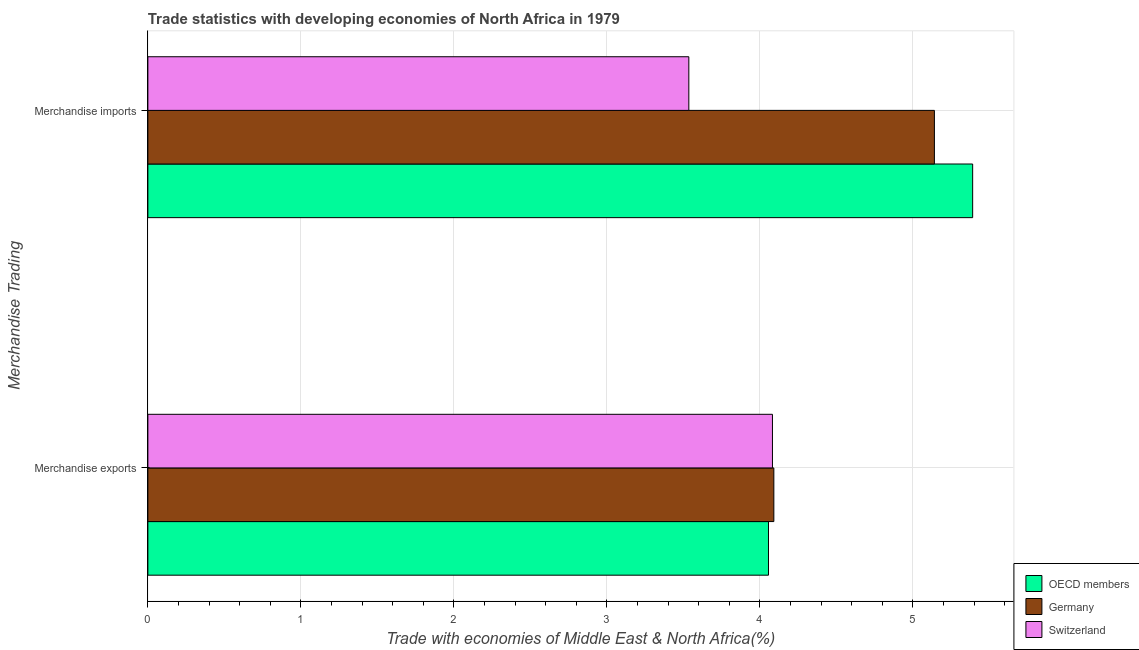How many different coloured bars are there?
Your answer should be compact. 3. How many groups of bars are there?
Ensure brevity in your answer.  2. How many bars are there on the 2nd tick from the top?
Your response must be concise. 3. What is the label of the 2nd group of bars from the top?
Offer a terse response. Merchandise exports. What is the merchandise imports in Germany?
Offer a terse response. 5.14. Across all countries, what is the maximum merchandise exports?
Ensure brevity in your answer.  4.09. Across all countries, what is the minimum merchandise exports?
Your answer should be very brief. 4.06. In which country was the merchandise exports maximum?
Make the answer very short. Germany. In which country was the merchandise exports minimum?
Your response must be concise. OECD members. What is the total merchandise imports in the graph?
Offer a terse response. 14.07. What is the difference between the merchandise imports in Germany and that in Switzerland?
Ensure brevity in your answer.  1.61. What is the difference between the merchandise exports in Switzerland and the merchandise imports in OECD members?
Provide a short and direct response. -1.31. What is the average merchandise imports per country?
Offer a very short reply. 4.69. What is the difference between the merchandise imports and merchandise exports in OECD members?
Make the answer very short. 1.33. What is the ratio of the merchandise imports in Switzerland to that in OECD members?
Offer a very short reply. 0.66. What does the 1st bar from the top in Merchandise exports represents?
Your answer should be compact. Switzerland. What is the difference between two consecutive major ticks on the X-axis?
Give a very brief answer. 1. Does the graph contain any zero values?
Offer a terse response. No. Does the graph contain grids?
Offer a very short reply. Yes. How are the legend labels stacked?
Offer a very short reply. Vertical. What is the title of the graph?
Make the answer very short. Trade statistics with developing economies of North Africa in 1979. Does "Guam" appear as one of the legend labels in the graph?
Make the answer very short. No. What is the label or title of the X-axis?
Provide a succinct answer. Trade with economies of Middle East & North Africa(%). What is the label or title of the Y-axis?
Offer a very short reply. Merchandise Trading. What is the Trade with economies of Middle East & North Africa(%) of OECD members in Merchandise exports?
Give a very brief answer. 4.06. What is the Trade with economies of Middle East & North Africa(%) of Germany in Merchandise exports?
Make the answer very short. 4.09. What is the Trade with economies of Middle East & North Africa(%) in Switzerland in Merchandise exports?
Make the answer very short. 4.08. What is the Trade with economies of Middle East & North Africa(%) in OECD members in Merchandise imports?
Your response must be concise. 5.39. What is the Trade with economies of Middle East & North Africa(%) of Germany in Merchandise imports?
Keep it short and to the point. 5.14. What is the Trade with economies of Middle East & North Africa(%) in Switzerland in Merchandise imports?
Offer a very short reply. 3.54. Across all Merchandise Trading, what is the maximum Trade with economies of Middle East & North Africa(%) of OECD members?
Provide a succinct answer. 5.39. Across all Merchandise Trading, what is the maximum Trade with economies of Middle East & North Africa(%) of Germany?
Offer a terse response. 5.14. Across all Merchandise Trading, what is the maximum Trade with economies of Middle East & North Africa(%) of Switzerland?
Keep it short and to the point. 4.08. Across all Merchandise Trading, what is the minimum Trade with economies of Middle East & North Africa(%) of OECD members?
Your answer should be compact. 4.06. Across all Merchandise Trading, what is the minimum Trade with economies of Middle East & North Africa(%) of Germany?
Your response must be concise. 4.09. Across all Merchandise Trading, what is the minimum Trade with economies of Middle East & North Africa(%) of Switzerland?
Ensure brevity in your answer.  3.54. What is the total Trade with economies of Middle East & North Africa(%) in OECD members in the graph?
Offer a terse response. 9.45. What is the total Trade with economies of Middle East & North Africa(%) of Germany in the graph?
Your answer should be very brief. 9.23. What is the total Trade with economies of Middle East & North Africa(%) in Switzerland in the graph?
Provide a succinct answer. 7.62. What is the difference between the Trade with economies of Middle East & North Africa(%) in OECD members in Merchandise exports and that in Merchandise imports?
Your answer should be compact. -1.33. What is the difference between the Trade with economies of Middle East & North Africa(%) in Germany in Merchandise exports and that in Merchandise imports?
Make the answer very short. -1.05. What is the difference between the Trade with economies of Middle East & North Africa(%) of Switzerland in Merchandise exports and that in Merchandise imports?
Your answer should be compact. 0.55. What is the difference between the Trade with economies of Middle East & North Africa(%) of OECD members in Merchandise exports and the Trade with economies of Middle East & North Africa(%) of Germany in Merchandise imports?
Make the answer very short. -1.08. What is the difference between the Trade with economies of Middle East & North Africa(%) of OECD members in Merchandise exports and the Trade with economies of Middle East & North Africa(%) of Switzerland in Merchandise imports?
Make the answer very short. 0.52. What is the difference between the Trade with economies of Middle East & North Africa(%) of Germany in Merchandise exports and the Trade with economies of Middle East & North Africa(%) of Switzerland in Merchandise imports?
Offer a terse response. 0.56. What is the average Trade with economies of Middle East & North Africa(%) of OECD members per Merchandise Trading?
Your response must be concise. 4.72. What is the average Trade with economies of Middle East & North Africa(%) of Germany per Merchandise Trading?
Your answer should be compact. 4.62. What is the average Trade with economies of Middle East & North Africa(%) in Switzerland per Merchandise Trading?
Ensure brevity in your answer.  3.81. What is the difference between the Trade with economies of Middle East & North Africa(%) in OECD members and Trade with economies of Middle East & North Africa(%) in Germany in Merchandise exports?
Your answer should be very brief. -0.04. What is the difference between the Trade with economies of Middle East & North Africa(%) in OECD members and Trade with economies of Middle East & North Africa(%) in Switzerland in Merchandise exports?
Your response must be concise. -0.03. What is the difference between the Trade with economies of Middle East & North Africa(%) in Germany and Trade with economies of Middle East & North Africa(%) in Switzerland in Merchandise exports?
Ensure brevity in your answer.  0.01. What is the difference between the Trade with economies of Middle East & North Africa(%) of OECD members and Trade with economies of Middle East & North Africa(%) of Switzerland in Merchandise imports?
Keep it short and to the point. 1.86. What is the difference between the Trade with economies of Middle East & North Africa(%) in Germany and Trade with economies of Middle East & North Africa(%) in Switzerland in Merchandise imports?
Ensure brevity in your answer.  1.61. What is the ratio of the Trade with economies of Middle East & North Africa(%) of OECD members in Merchandise exports to that in Merchandise imports?
Your answer should be compact. 0.75. What is the ratio of the Trade with economies of Middle East & North Africa(%) in Germany in Merchandise exports to that in Merchandise imports?
Keep it short and to the point. 0.8. What is the ratio of the Trade with economies of Middle East & North Africa(%) of Switzerland in Merchandise exports to that in Merchandise imports?
Your answer should be very brief. 1.15. What is the difference between the highest and the second highest Trade with economies of Middle East & North Africa(%) in OECD members?
Your answer should be compact. 1.33. What is the difference between the highest and the second highest Trade with economies of Middle East & North Africa(%) in Germany?
Your answer should be very brief. 1.05. What is the difference between the highest and the second highest Trade with economies of Middle East & North Africa(%) of Switzerland?
Keep it short and to the point. 0.55. What is the difference between the highest and the lowest Trade with economies of Middle East & North Africa(%) of OECD members?
Keep it short and to the point. 1.33. What is the difference between the highest and the lowest Trade with economies of Middle East & North Africa(%) of Germany?
Your response must be concise. 1.05. What is the difference between the highest and the lowest Trade with economies of Middle East & North Africa(%) in Switzerland?
Offer a terse response. 0.55. 